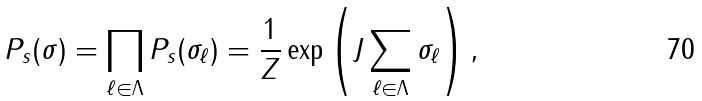<formula> <loc_0><loc_0><loc_500><loc_500>P _ { s } ( \sigma ) = \prod _ { \ell \in \Lambda } P _ { s } ( \sigma _ { \ell } ) = \frac { 1 } { Z } \exp \left ( J \sum _ { \ell \in \Lambda } \sigma _ { \ell } \right ) ,</formula> 